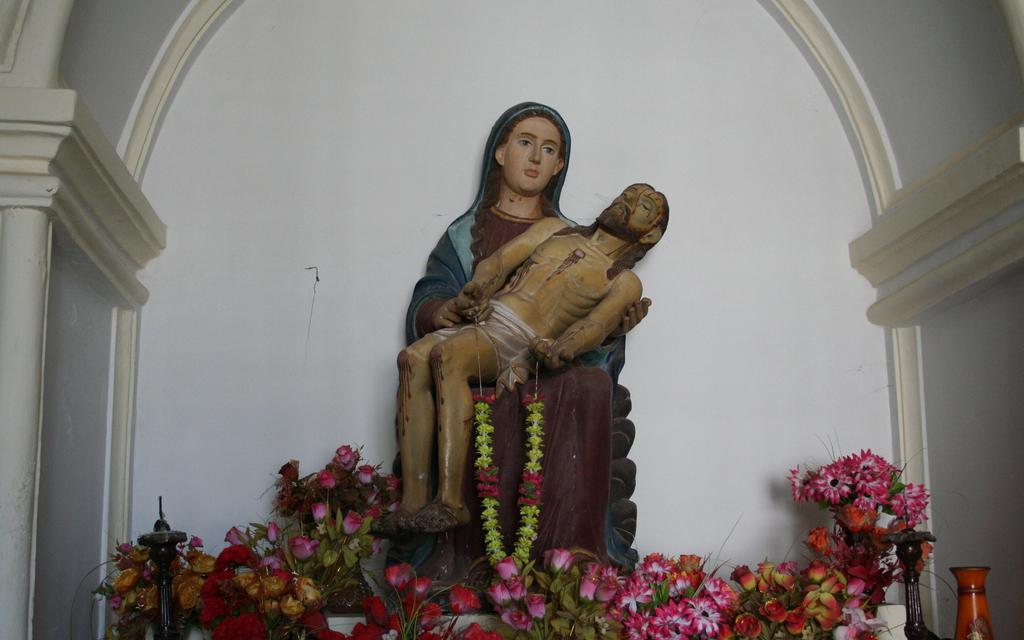How would you summarize this image in a sentence or two? In this image we can see a statue of a woman holding a man and man holding a garland, there are few flowers and flower vases in front of the statue, there is a pillar on the left side and wall in the background. 